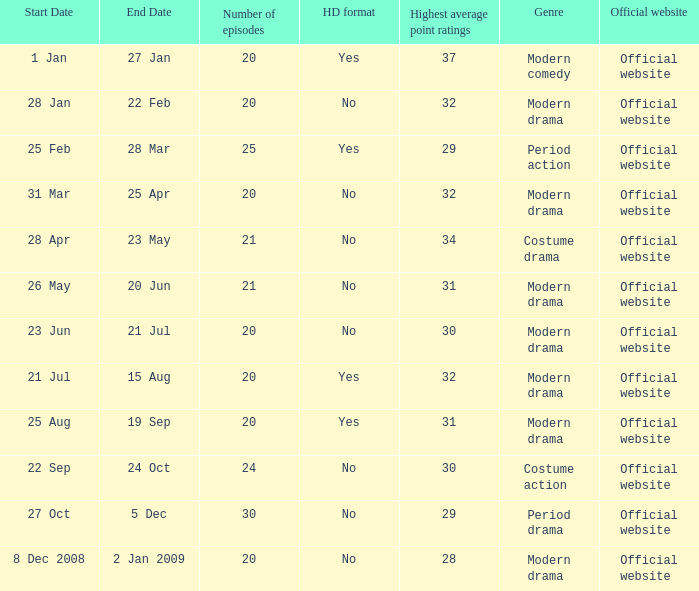What are the number of episodes when the genre is modern drama and the highest average ratings points are 28? 20.0. 